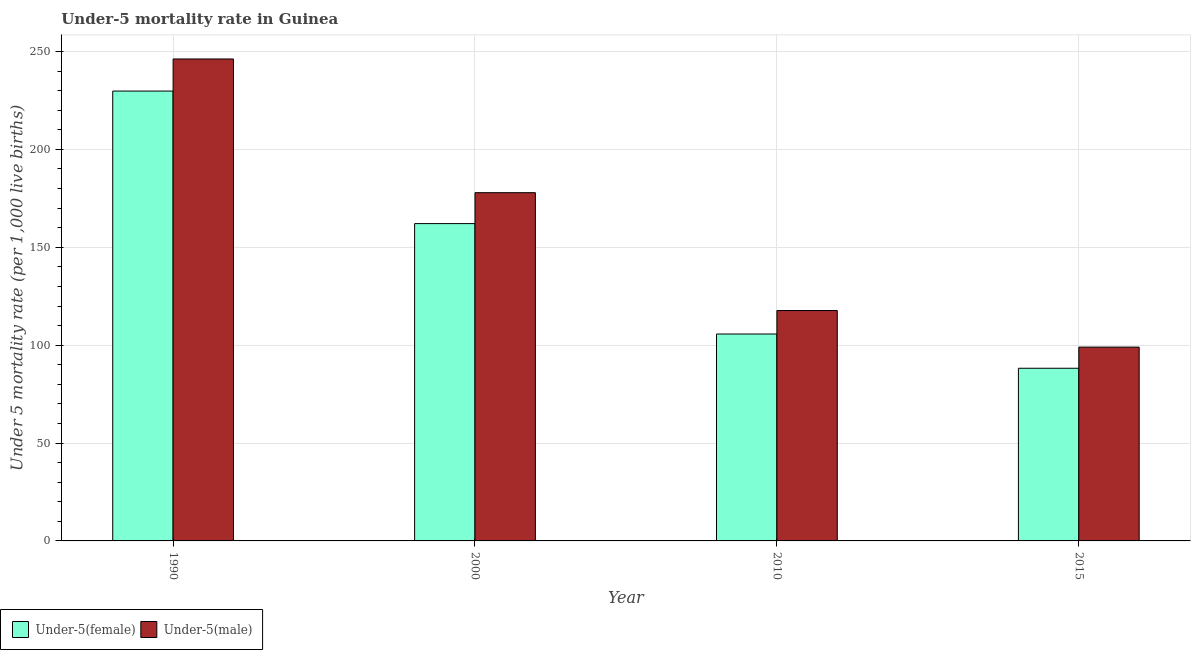How many different coloured bars are there?
Offer a very short reply. 2. Are the number of bars on each tick of the X-axis equal?
Your answer should be very brief. Yes. How many bars are there on the 4th tick from the left?
Your response must be concise. 2. In how many cases, is the number of bars for a given year not equal to the number of legend labels?
Your answer should be very brief. 0. What is the under-5 male mortality rate in 2000?
Provide a short and direct response. 177.9. Across all years, what is the maximum under-5 male mortality rate?
Your answer should be very brief. 246.2. Across all years, what is the minimum under-5 male mortality rate?
Your answer should be very brief. 99. In which year was the under-5 male mortality rate maximum?
Offer a terse response. 1990. In which year was the under-5 male mortality rate minimum?
Offer a very short reply. 2015. What is the total under-5 female mortality rate in the graph?
Ensure brevity in your answer.  585.8. What is the difference between the under-5 male mortality rate in 2000 and that in 2015?
Offer a terse response. 78.9. What is the difference between the under-5 female mortality rate in 2015 and the under-5 male mortality rate in 2010?
Provide a short and direct response. -17.5. What is the average under-5 male mortality rate per year?
Offer a terse response. 160.2. What is the ratio of the under-5 female mortality rate in 2000 to that in 2010?
Your answer should be very brief. 1.53. What is the difference between the highest and the second highest under-5 female mortality rate?
Your answer should be very brief. 67.7. What is the difference between the highest and the lowest under-5 male mortality rate?
Your answer should be very brief. 147.2. In how many years, is the under-5 male mortality rate greater than the average under-5 male mortality rate taken over all years?
Offer a terse response. 2. Is the sum of the under-5 male mortality rate in 2000 and 2010 greater than the maximum under-5 female mortality rate across all years?
Ensure brevity in your answer.  Yes. What does the 2nd bar from the left in 1990 represents?
Your answer should be compact. Under-5(male). What does the 2nd bar from the right in 2015 represents?
Ensure brevity in your answer.  Under-5(female). How many bars are there?
Your answer should be compact. 8. Are all the bars in the graph horizontal?
Give a very brief answer. No. How many years are there in the graph?
Your answer should be very brief. 4. Are the values on the major ticks of Y-axis written in scientific E-notation?
Offer a terse response. No. How many legend labels are there?
Give a very brief answer. 2. How are the legend labels stacked?
Keep it short and to the point. Horizontal. What is the title of the graph?
Offer a very short reply. Under-5 mortality rate in Guinea. Does "Age 15+" appear as one of the legend labels in the graph?
Offer a terse response. No. What is the label or title of the X-axis?
Provide a succinct answer. Year. What is the label or title of the Y-axis?
Keep it short and to the point. Under 5 mortality rate (per 1,0 live births). What is the Under 5 mortality rate (per 1,000 live births) in Under-5(female) in 1990?
Your answer should be compact. 229.8. What is the Under 5 mortality rate (per 1,000 live births) in Under-5(male) in 1990?
Your answer should be very brief. 246.2. What is the Under 5 mortality rate (per 1,000 live births) of Under-5(female) in 2000?
Your response must be concise. 162.1. What is the Under 5 mortality rate (per 1,000 live births) of Under-5(male) in 2000?
Provide a succinct answer. 177.9. What is the Under 5 mortality rate (per 1,000 live births) in Under-5(female) in 2010?
Make the answer very short. 105.7. What is the Under 5 mortality rate (per 1,000 live births) of Under-5(male) in 2010?
Ensure brevity in your answer.  117.7. What is the Under 5 mortality rate (per 1,000 live births) of Under-5(female) in 2015?
Your answer should be compact. 88.2. Across all years, what is the maximum Under 5 mortality rate (per 1,000 live births) in Under-5(female)?
Keep it short and to the point. 229.8. Across all years, what is the maximum Under 5 mortality rate (per 1,000 live births) in Under-5(male)?
Offer a terse response. 246.2. Across all years, what is the minimum Under 5 mortality rate (per 1,000 live births) of Under-5(female)?
Provide a succinct answer. 88.2. Across all years, what is the minimum Under 5 mortality rate (per 1,000 live births) of Under-5(male)?
Provide a succinct answer. 99. What is the total Under 5 mortality rate (per 1,000 live births) of Under-5(female) in the graph?
Provide a short and direct response. 585.8. What is the total Under 5 mortality rate (per 1,000 live births) of Under-5(male) in the graph?
Keep it short and to the point. 640.8. What is the difference between the Under 5 mortality rate (per 1,000 live births) in Under-5(female) in 1990 and that in 2000?
Keep it short and to the point. 67.7. What is the difference between the Under 5 mortality rate (per 1,000 live births) in Under-5(male) in 1990 and that in 2000?
Offer a terse response. 68.3. What is the difference between the Under 5 mortality rate (per 1,000 live births) in Under-5(female) in 1990 and that in 2010?
Keep it short and to the point. 124.1. What is the difference between the Under 5 mortality rate (per 1,000 live births) in Under-5(male) in 1990 and that in 2010?
Provide a succinct answer. 128.5. What is the difference between the Under 5 mortality rate (per 1,000 live births) in Under-5(female) in 1990 and that in 2015?
Keep it short and to the point. 141.6. What is the difference between the Under 5 mortality rate (per 1,000 live births) in Under-5(male) in 1990 and that in 2015?
Your response must be concise. 147.2. What is the difference between the Under 5 mortality rate (per 1,000 live births) in Under-5(female) in 2000 and that in 2010?
Provide a short and direct response. 56.4. What is the difference between the Under 5 mortality rate (per 1,000 live births) in Under-5(male) in 2000 and that in 2010?
Ensure brevity in your answer.  60.2. What is the difference between the Under 5 mortality rate (per 1,000 live births) in Under-5(female) in 2000 and that in 2015?
Your response must be concise. 73.9. What is the difference between the Under 5 mortality rate (per 1,000 live births) of Under-5(male) in 2000 and that in 2015?
Offer a very short reply. 78.9. What is the difference between the Under 5 mortality rate (per 1,000 live births) of Under-5(female) in 2010 and that in 2015?
Your response must be concise. 17.5. What is the difference between the Under 5 mortality rate (per 1,000 live births) of Under-5(male) in 2010 and that in 2015?
Make the answer very short. 18.7. What is the difference between the Under 5 mortality rate (per 1,000 live births) of Under-5(female) in 1990 and the Under 5 mortality rate (per 1,000 live births) of Under-5(male) in 2000?
Keep it short and to the point. 51.9. What is the difference between the Under 5 mortality rate (per 1,000 live births) of Under-5(female) in 1990 and the Under 5 mortality rate (per 1,000 live births) of Under-5(male) in 2010?
Offer a very short reply. 112.1. What is the difference between the Under 5 mortality rate (per 1,000 live births) in Under-5(female) in 1990 and the Under 5 mortality rate (per 1,000 live births) in Under-5(male) in 2015?
Provide a short and direct response. 130.8. What is the difference between the Under 5 mortality rate (per 1,000 live births) of Under-5(female) in 2000 and the Under 5 mortality rate (per 1,000 live births) of Under-5(male) in 2010?
Give a very brief answer. 44.4. What is the difference between the Under 5 mortality rate (per 1,000 live births) of Under-5(female) in 2000 and the Under 5 mortality rate (per 1,000 live births) of Under-5(male) in 2015?
Give a very brief answer. 63.1. What is the difference between the Under 5 mortality rate (per 1,000 live births) of Under-5(female) in 2010 and the Under 5 mortality rate (per 1,000 live births) of Under-5(male) in 2015?
Provide a succinct answer. 6.7. What is the average Under 5 mortality rate (per 1,000 live births) of Under-5(female) per year?
Provide a short and direct response. 146.45. What is the average Under 5 mortality rate (per 1,000 live births) of Under-5(male) per year?
Offer a very short reply. 160.2. In the year 1990, what is the difference between the Under 5 mortality rate (per 1,000 live births) of Under-5(female) and Under 5 mortality rate (per 1,000 live births) of Under-5(male)?
Offer a terse response. -16.4. In the year 2000, what is the difference between the Under 5 mortality rate (per 1,000 live births) of Under-5(female) and Under 5 mortality rate (per 1,000 live births) of Under-5(male)?
Keep it short and to the point. -15.8. What is the ratio of the Under 5 mortality rate (per 1,000 live births) of Under-5(female) in 1990 to that in 2000?
Provide a succinct answer. 1.42. What is the ratio of the Under 5 mortality rate (per 1,000 live births) in Under-5(male) in 1990 to that in 2000?
Your answer should be very brief. 1.38. What is the ratio of the Under 5 mortality rate (per 1,000 live births) in Under-5(female) in 1990 to that in 2010?
Give a very brief answer. 2.17. What is the ratio of the Under 5 mortality rate (per 1,000 live births) in Under-5(male) in 1990 to that in 2010?
Your answer should be compact. 2.09. What is the ratio of the Under 5 mortality rate (per 1,000 live births) of Under-5(female) in 1990 to that in 2015?
Your answer should be very brief. 2.61. What is the ratio of the Under 5 mortality rate (per 1,000 live births) in Under-5(male) in 1990 to that in 2015?
Your answer should be compact. 2.49. What is the ratio of the Under 5 mortality rate (per 1,000 live births) of Under-5(female) in 2000 to that in 2010?
Provide a short and direct response. 1.53. What is the ratio of the Under 5 mortality rate (per 1,000 live births) in Under-5(male) in 2000 to that in 2010?
Offer a very short reply. 1.51. What is the ratio of the Under 5 mortality rate (per 1,000 live births) of Under-5(female) in 2000 to that in 2015?
Offer a very short reply. 1.84. What is the ratio of the Under 5 mortality rate (per 1,000 live births) in Under-5(male) in 2000 to that in 2015?
Provide a short and direct response. 1.8. What is the ratio of the Under 5 mortality rate (per 1,000 live births) of Under-5(female) in 2010 to that in 2015?
Keep it short and to the point. 1.2. What is the ratio of the Under 5 mortality rate (per 1,000 live births) in Under-5(male) in 2010 to that in 2015?
Offer a very short reply. 1.19. What is the difference between the highest and the second highest Under 5 mortality rate (per 1,000 live births) of Under-5(female)?
Offer a very short reply. 67.7. What is the difference between the highest and the second highest Under 5 mortality rate (per 1,000 live births) of Under-5(male)?
Offer a very short reply. 68.3. What is the difference between the highest and the lowest Under 5 mortality rate (per 1,000 live births) of Under-5(female)?
Give a very brief answer. 141.6. What is the difference between the highest and the lowest Under 5 mortality rate (per 1,000 live births) in Under-5(male)?
Provide a short and direct response. 147.2. 